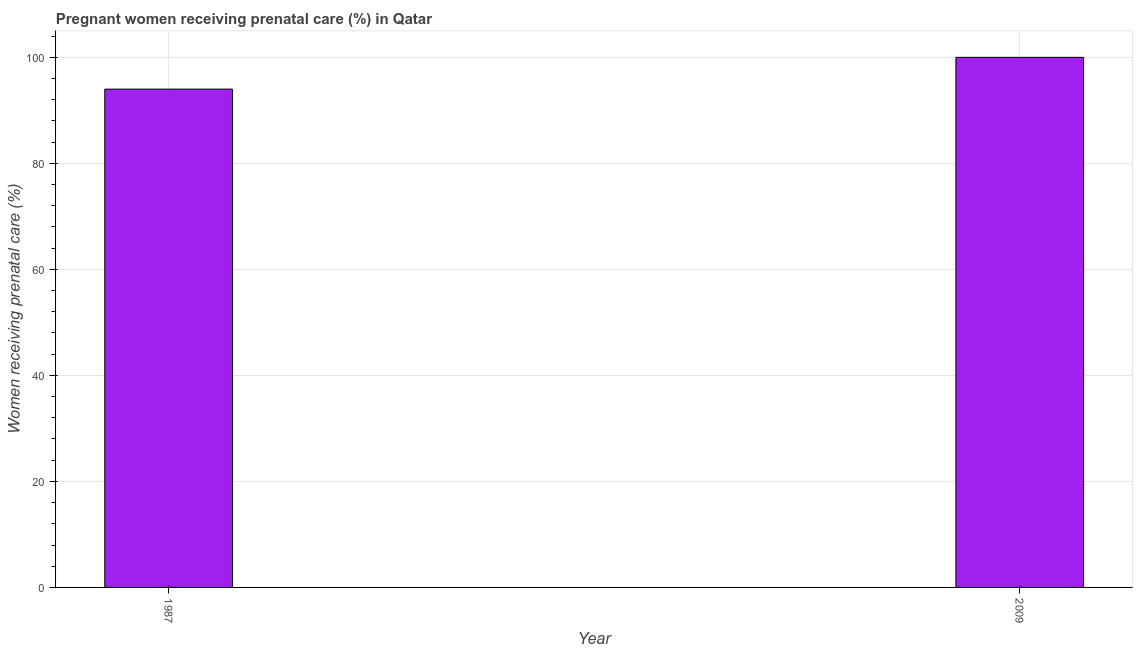Does the graph contain any zero values?
Your answer should be compact. No. Does the graph contain grids?
Your answer should be very brief. Yes. What is the title of the graph?
Provide a short and direct response. Pregnant women receiving prenatal care (%) in Qatar. What is the label or title of the X-axis?
Provide a succinct answer. Year. What is the label or title of the Y-axis?
Offer a terse response. Women receiving prenatal care (%). What is the percentage of pregnant women receiving prenatal care in 2009?
Keep it short and to the point. 100. Across all years, what is the maximum percentage of pregnant women receiving prenatal care?
Make the answer very short. 100. Across all years, what is the minimum percentage of pregnant women receiving prenatal care?
Make the answer very short. 94. In which year was the percentage of pregnant women receiving prenatal care minimum?
Give a very brief answer. 1987. What is the sum of the percentage of pregnant women receiving prenatal care?
Your answer should be very brief. 194. What is the difference between the percentage of pregnant women receiving prenatal care in 1987 and 2009?
Make the answer very short. -6. What is the average percentage of pregnant women receiving prenatal care per year?
Ensure brevity in your answer.  97. What is the median percentage of pregnant women receiving prenatal care?
Provide a succinct answer. 97. In how many years, is the percentage of pregnant women receiving prenatal care greater than 72 %?
Ensure brevity in your answer.  2. What is the ratio of the percentage of pregnant women receiving prenatal care in 1987 to that in 2009?
Keep it short and to the point. 0.94. Is the percentage of pregnant women receiving prenatal care in 1987 less than that in 2009?
Ensure brevity in your answer.  Yes. In how many years, is the percentage of pregnant women receiving prenatal care greater than the average percentage of pregnant women receiving prenatal care taken over all years?
Make the answer very short. 1. Are all the bars in the graph horizontal?
Your answer should be very brief. No. Are the values on the major ticks of Y-axis written in scientific E-notation?
Offer a terse response. No. What is the Women receiving prenatal care (%) in 1987?
Provide a succinct answer. 94. What is the Women receiving prenatal care (%) of 2009?
Provide a succinct answer. 100. 